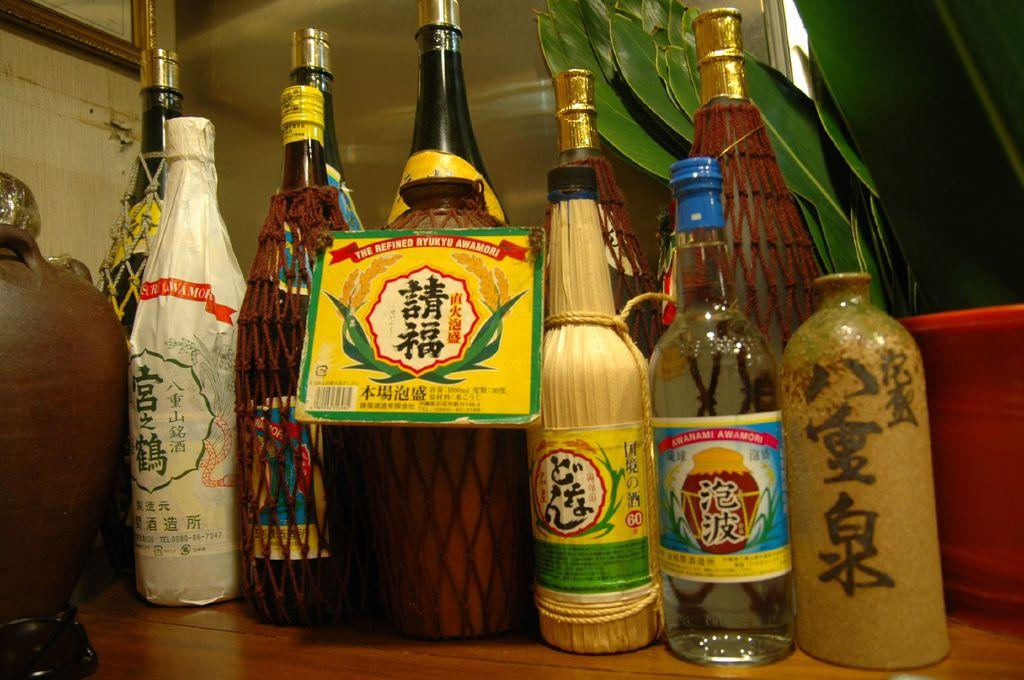<image>
Render a clear and concise summary of the photo. A group of different sized Asian sauce bottles lined up on a wood table 